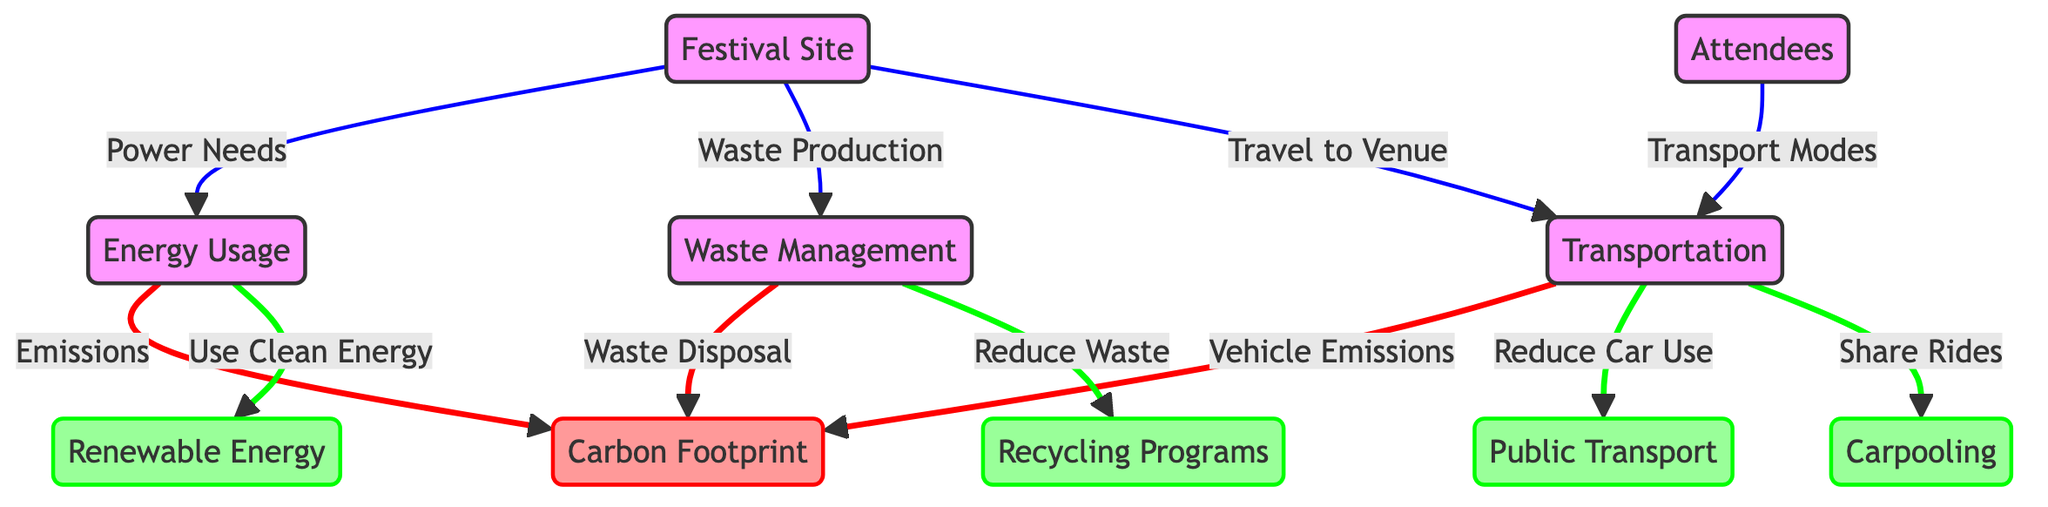What are the main factors contributing to the carbon footprint? The diagram indicates that transportation, energy usage, and waste management are the primary factors that contribute to the carbon footprint. Each of these factors is linked with a direct arrow to the carbon footprint node, indicating their contributions.
Answer: Transportation, energy usage, waste management What connects festival site to waste management? The connection between the festival site and waste management is labeled "Waste Production", which indicates that the festival site is a source of waste that needs to be managed. The arrow from festival site to waste management shows this direct relationship.
Answer: Waste Production What type of energy is emphasized in the diagram as a solution? The diagram highlights "Renewable Energy" as a solution by connecting the energy usage node to the renewable energy node with a direct arrow, indicating its importance in reducing the carbon footprint.
Answer: Renewable Energy How many nodes are classified as solutions in the diagram? There are four nodes classified as solutions: Recycling Programs, Renewable Energy, Public Transport, and Carpooling. Each of these nodes is visually denoted in green, which indicates they are strategies to mitigate impacts.
Answer: Four What is the relationship between waste management and recycling programs? The relationship indicated in the diagram shows that waste management aims to "Reduce Waste" through recycling programs. The arrow leads from waste management to recycling programs, depicting a direct impact of waste management efforts.
Answer: Reduce Waste Which stakeholder influences transportation modes? The diagram indicates that "Attendees" influence transportation modes, as there is an arrow leading from the attendees node to the transportation node, signifying their role in determining how they travel to the festival.
Answer: Attendees Which solution aims to reduce car use? The diagram explicitly states that "Public Transport" is the solution aimed at reducing car use, represented by the arrow connecting transportation to the public transport node in green.
Answer: Public Transport What are two ways transportation impacts carbon footprint? Transportation affects the carbon footprint through vehicle emissions and by affecting transport modes for attendees. The diagram shows these connections with arrows leading directly to the carbon footprint node.
Answer: Vehicle Emissions, Transport Modes 